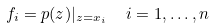<formula> <loc_0><loc_0><loc_500><loc_500>f _ { i } = p ( z ) | _ { z = x _ { i } } \ \ i = 1 , \dots , n</formula> 